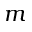<formula> <loc_0><loc_0><loc_500><loc_500>m</formula> 